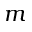<formula> <loc_0><loc_0><loc_500><loc_500>m</formula> 